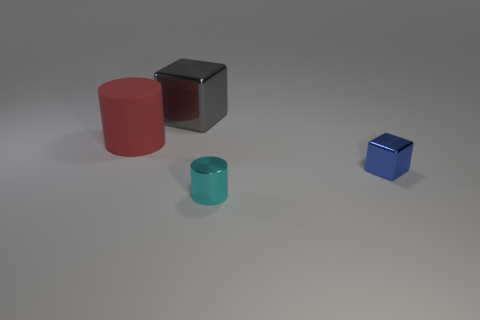What materials do the objects in the image appear to be made from? The objects in the image seem to be made from various materials, displaying different textures and reflections. The cylinder on the left appears to have a matte surface, likely painted metal or plastic, while the cube in the center has reflective sides, suggesting it could be metallic. The small cylinder has a translucent appearance that could be glass or acrylic, and the cube on the right looks like it might be made of a different type of metal or plastic with a matte finish. 